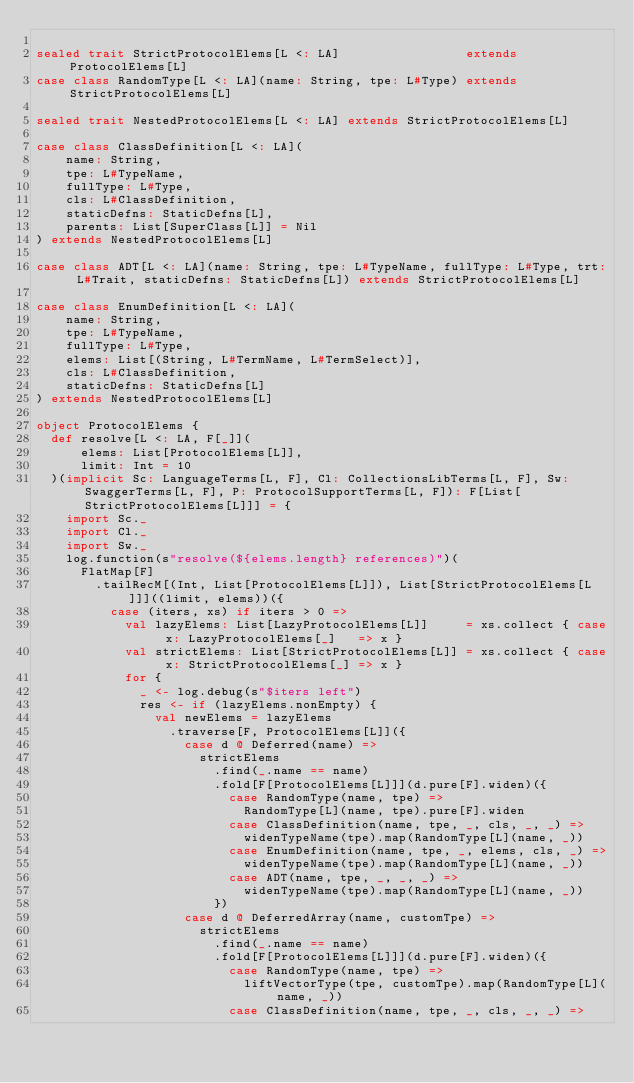<code> <loc_0><loc_0><loc_500><loc_500><_Scala_>
sealed trait StrictProtocolElems[L <: LA]                 extends ProtocolElems[L]
case class RandomType[L <: LA](name: String, tpe: L#Type) extends StrictProtocolElems[L]

sealed trait NestedProtocolElems[L <: LA] extends StrictProtocolElems[L]

case class ClassDefinition[L <: LA](
    name: String,
    tpe: L#TypeName,
    fullType: L#Type,
    cls: L#ClassDefinition,
    staticDefns: StaticDefns[L],
    parents: List[SuperClass[L]] = Nil
) extends NestedProtocolElems[L]

case class ADT[L <: LA](name: String, tpe: L#TypeName, fullType: L#Type, trt: L#Trait, staticDefns: StaticDefns[L]) extends StrictProtocolElems[L]

case class EnumDefinition[L <: LA](
    name: String,
    tpe: L#TypeName,
    fullType: L#Type,
    elems: List[(String, L#TermName, L#TermSelect)],
    cls: L#ClassDefinition,
    staticDefns: StaticDefns[L]
) extends NestedProtocolElems[L]

object ProtocolElems {
  def resolve[L <: LA, F[_]](
      elems: List[ProtocolElems[L]],
      limit: Int = 10
  )(implicit Sc: LanguageTerms[L, F], Cl: CollectionsLibTerms[L, F], Sw: SwaggerTerms[L, F], P: ProtocolSupportTerms[L, F]): F[List[StrictProtocolElems[L]]] = {
    import Sc._
    import Cl._
    import Sw._
    log.function(s"resolve(${elems.length} references)")(
      FlatMap[F]
        .tailRecM[(Int, List[ProtocolElems[L]]), List[StrictProtocolElems[L]]]((limit, elems))({
          case (iters, xs) if iters > 0 =>
            val lazyElems: List[LazyProtocolElems[L]]     = xs.collect { case x: LazyProtocolElems[_]   => x }
            val strictElems: List[StrictProtocolElems[L]] = xs.collect { case x: StrictProtocolElems[_] => x }
            for {
              _ <- log.debug(s"$iters left")
              res <- if (lazyElems.nonEmpty) {
                val newElems = lazyElems
                  .traverse[F, ProtocolElems[L]]({
                    case d @ Deferred(name) =>
                      strictElems
                        .find(_.name == name)
                        .fold[F[ProtocolElems[L]]](d.pure[F].widen)({
                          case RandomType(name, tpe) =>
                            RandomType[L](name, tpe).pure[F].widen
                          case ClassDefinition(name, tpe, _, cls, _, _) =>
                            widenTypeName(tpe).map(RandomType[L](name, _))
                          case EnumDefinition(name, tpe, _, elems, cls, _) =>
                            widenTypeName(tpe).map(RandomType[L](name, _))
                          case ADT(name, tpe, _, _, _) =>
                            widenTypeName(tpe).map(RandomType[L](name, _))
                        })
                    case d @ DeferredArray(name, customTpe) =>
                      strictElems
                        .find(_.name == name)
                        .fold[F[ProtocolElems[L]]](d.pure[F].widen)({
                          case RandomType(name, tpe) =>
                            liftVectorType(tpe, customTpe).map(RandomType[L](name, _))
                          case ClassDefinition(name, tpe, _, cls, _, _) =></code> 